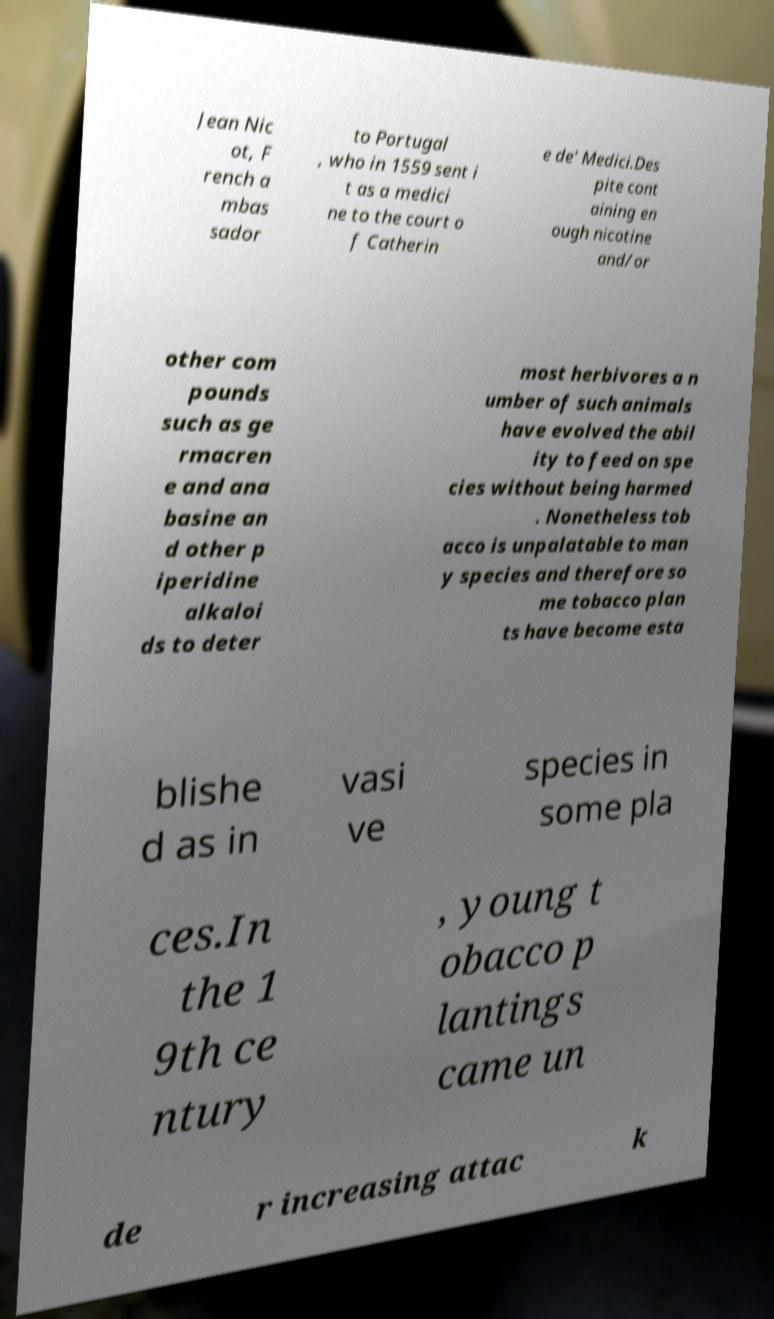Please identify and transcribe the text found in this image. Jean Nic ot, F rench a mbas sador to Portugal , who in 1559 sent i t as a medici ne to the court o f Catherin e de' Medici.Des pite cont aining en ough nicotine and/or other com pounds such as ge rmacren e and ana basine an d other p iperidine alkaloi ds to deter most herbivores a n umber of such animals have evolved the abil ity to feed on spe cies without being harmed . Nonetheless tob acco is unpalatable to man y species and therefore so me tobacco plan ts have become esta blishe d as in vasi ve species in some pla ces.In the 1 9th ce ntury , young t obacco p lantings came un de r increasing attac k 